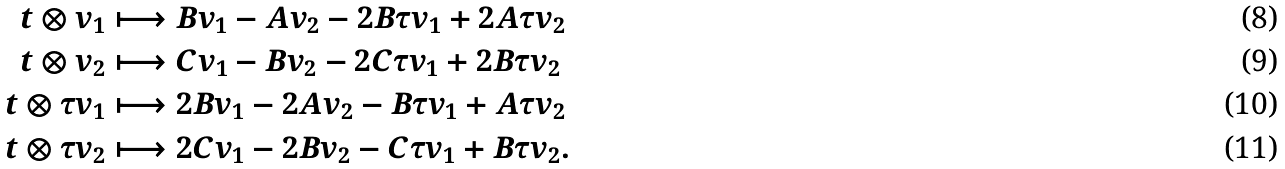<formula> <loc_0><loc_0><loc_500><loc_500>t \otimes v _ { 1 } & \longmapsto B v _ { 1 } - A v _ { 2 } - 2 B \tau v _ { 1 } + 2 A \tau v _ { 2 } \\ t \otimes v _ { 2 } & \longmapsto C v _ { 1 } - B v _ { 2 } - 2 C \tau v _ { 1 } + 2 B \tau v _ { 2 } \\ t \otimes \tau v _ { 1 } & \longmapsto 2 B v _ { 1 } - 2 A v _ { 2 } - B \tau v _ { 1 } + A \tau v _ { 2 } \\ t \otimes \tau v _ { 2 } & \longmapsto 2 C v _ { 1 } - 2 B v _ { 2 } - C \tau v _ { 1 } + B \tau v _ { 2 } .</formula> 